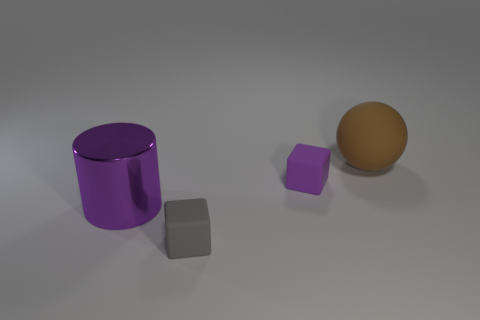Is there any other thing that has the same material as the large purple cylinder?
Your answer should be very brief. No. What number of tiny things are either purple things or purple metallic things?
Your answer should be very brief. 1. Do the big brown object and the large purple cylinder have the same material?
Ensure brevity in your answer.  No. There is a purple thing right of the tiny gray cube; what number of large spheres are behind it?
Your answer should be very brief. 1. Are there any gray things of the same shape as the tiny purple object?
Give a very brief answer. Yes. There is a small object behind the big cylinder; is its shape the same as the tiny rubber thing on the left side of the purple rubber cube?
Give a very brief answer. Yes. The object that is both to the left of the brown object and right of the gray cube has what shape?
Make the answer very short. Cube. Is there a gray block of the same size as the brown matte thing?
Ensure brevity in your answer.  No. Does the large sphere have the same color as the big object left of the large matte ball?
Ensure brevity in your answer.  No. What is the material of the gray block?
Ensure brevity in your answer.  Rubber. 